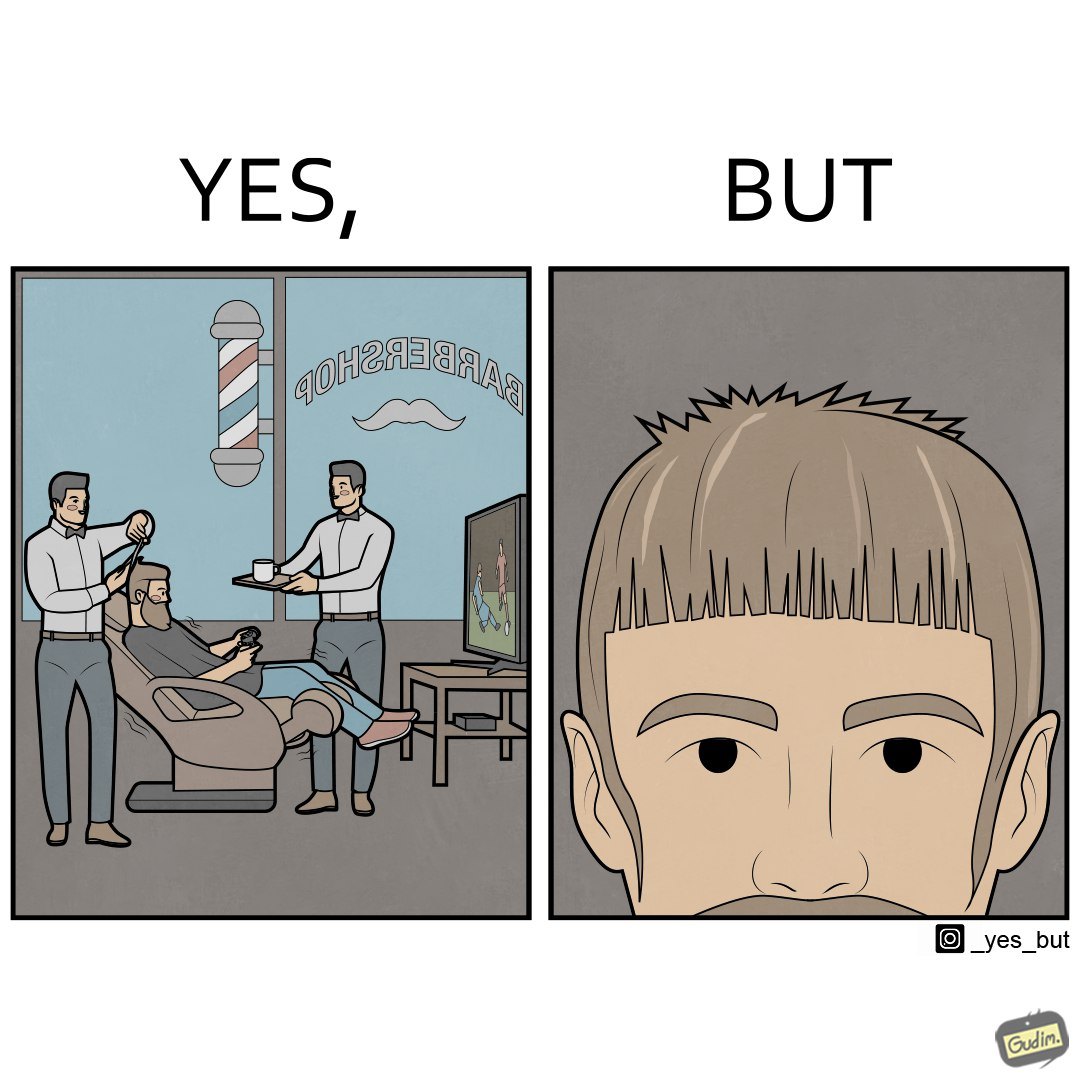What is the satirical meaning behind this image? The image is ironic, because the sole purpose of the person was to get a hair cut but he became so much engrossed in the game that the barber wasn't able to cut his hairs properly. and even the saloon is providing so many facilities but they don't have a good hairdresser 